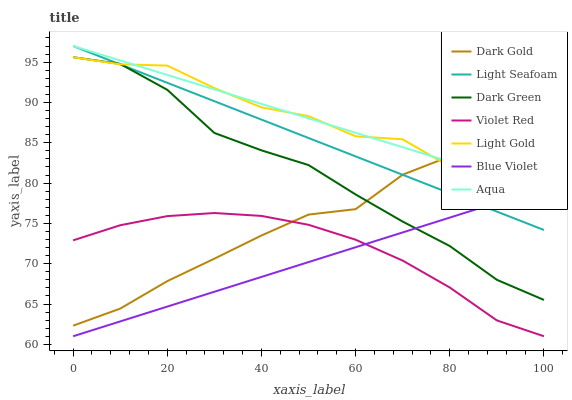Does Blue Violet have the minimum area under the curve?
Answer yes or no. Yes. Does Aqua have the maximum area under the curve?
Answer yes or no. Yes. Does Dark Gold have the minimum area under the curve?
Answer yes or no. No. Does Dark Gold have the maximum area under the curve?
Answer yes or no. No. Is Aqua the smoothest?
Answer yes or no. Yes. Is Dark Gold the roughest?
Answer yes or no. Yes. Is Dark Gold the smoothest?
Answer yes or no. No. Is Aqua the roughest?
Answer yes or no. No. Does Violet Red have the lowest value?
Answer yes or no. Yes. Does Dark Gold have the lowest value?
Answer yes or no. No. Does Light Seafoam have the highest value?
Answer yes or no. Yes. Does Dark Gold have the highest value?
Answer yes or no. No. Is Violet Red less than Aqua?
Answer yes or no. Yes. Is Aqua greater than Violet Red?
Answer yes or no. Yes. Does Blue Violet intersect Dark Green?
Answer yes or no. Yes. Is Blue Violet less than Dark Green?
Answer yes or no. No. Is Blue Violet greater than Dark Green?
Answer yes or no. No. Does Violet Red intersect Aqua?
Answer yes or no. No. 